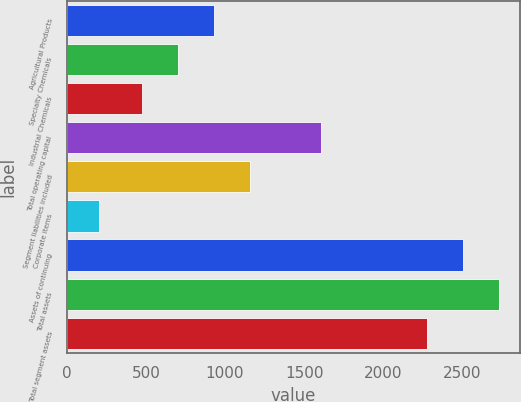<chart> <loc_0><loc_0><loc_500><loc_500><bar_chart><fcel>Agricultural Products<fcel>Specialty Chemicals<fcel>Industrial Chemicals<fcel>Total operating capital<fcel>Segment liabilities included<fcel>Corporate items<fcel>Assets of continuing<fcel>Total assets<fcel>Total segment assets<nl><fcel>932.76<fcel>705.33<fcel>477.9<fcel>1604.8<fcel>1160.19<fcel>202.9<fcel>2501.73<fcel>2729.16<fcel>2274.3<nl></chart> 